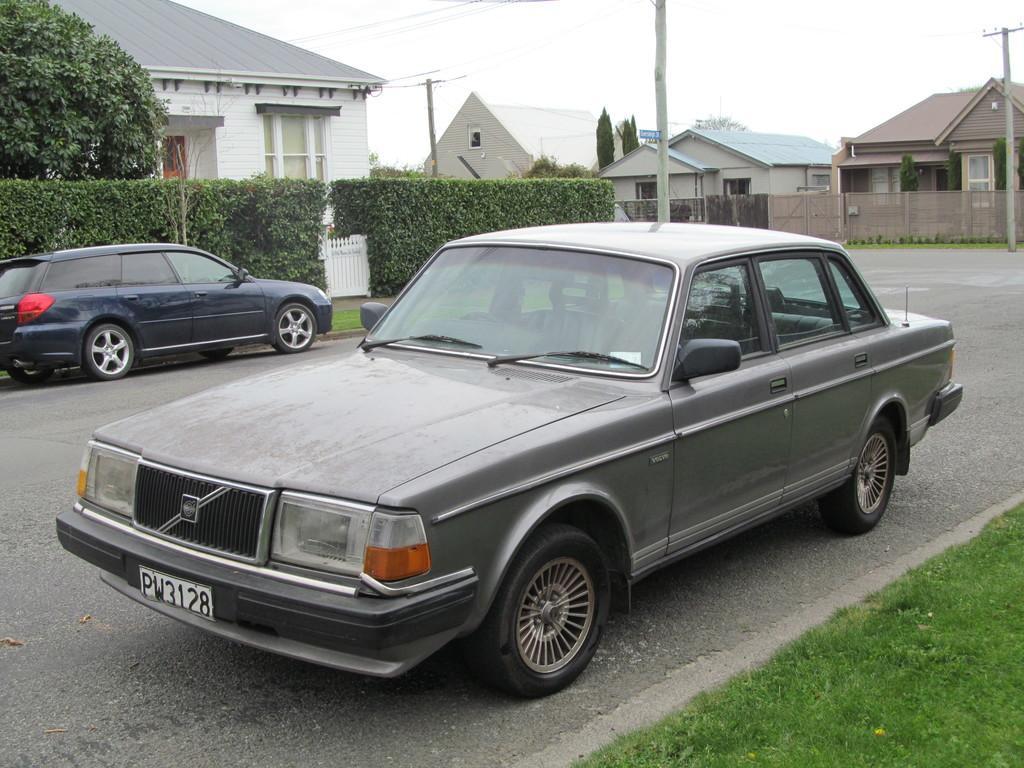How would you summarize this image in a sentence or two? In this image, we can see some poles and shelter houses. There are plants beside the road. There is a tree in the top left of the image. There are cars on the road. There is a grass in the bottom right of the image. 